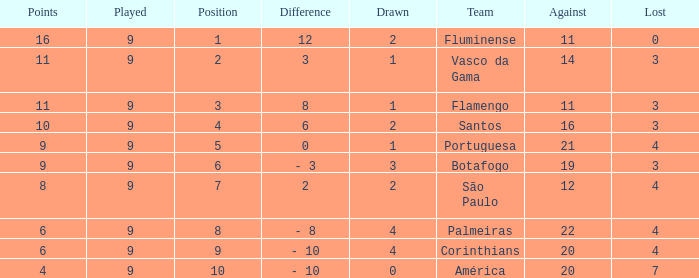Which Lost is the highest one that has a Drawn smaller than 4, and a Played smaller than 9? None. I'm looking to parse the entire table for insights. Could you assist me with that? {'header': ['Points', 'Played', 'Position', 'Difference', 'Drawn', 'Team', 'Against', 'Lost'], 'rows': [['16', '9', '1', '12', '2', 'Fluminense', '11', '0'], ['11', '9', '2', '3', '1', 'Vasco da Gama', '14', '3'], ['11', '9', '3', '8', '1', 'Flamengo', '11', '3'], ['10', '9', '4', '6', '2', 'Santos', '16', '3'], ['9', '9', '5', '0', '1', 'Portuguesa', '21', '4'], ['9', '9', '6', '- 3', '3', 'Botafogo', '19', '3'], ['8', '9', '7', '2', '2', 'São Paulo', '12', '4'], ['6', '9', '8', '- 8', '4', 'Palmeiras', '22', '4'], ['6', '9', '9', '- 10', '4', 'Corinthians', '20', '4'], ['4', '9', '10', '- 10', '0', 'América', '20', '7']]} 